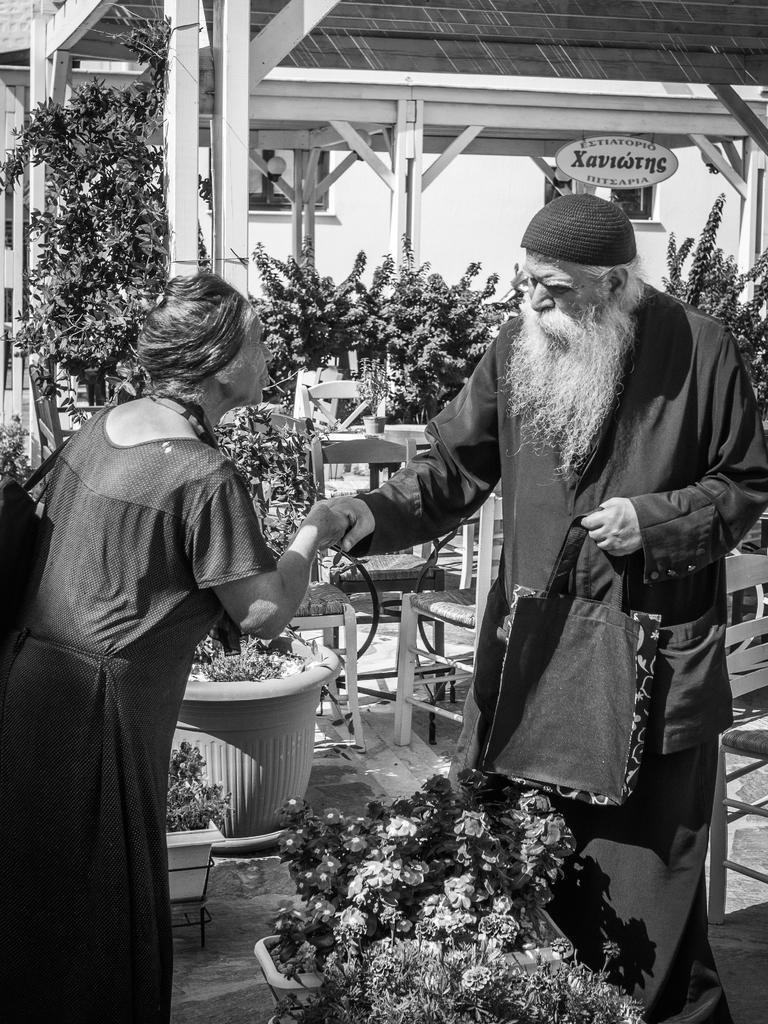Could you give a brief overview of what you see in this image? In this image we can see two people standing and shaking their hands. At the bottom there are plants. In the background there are chairs and sheds. 